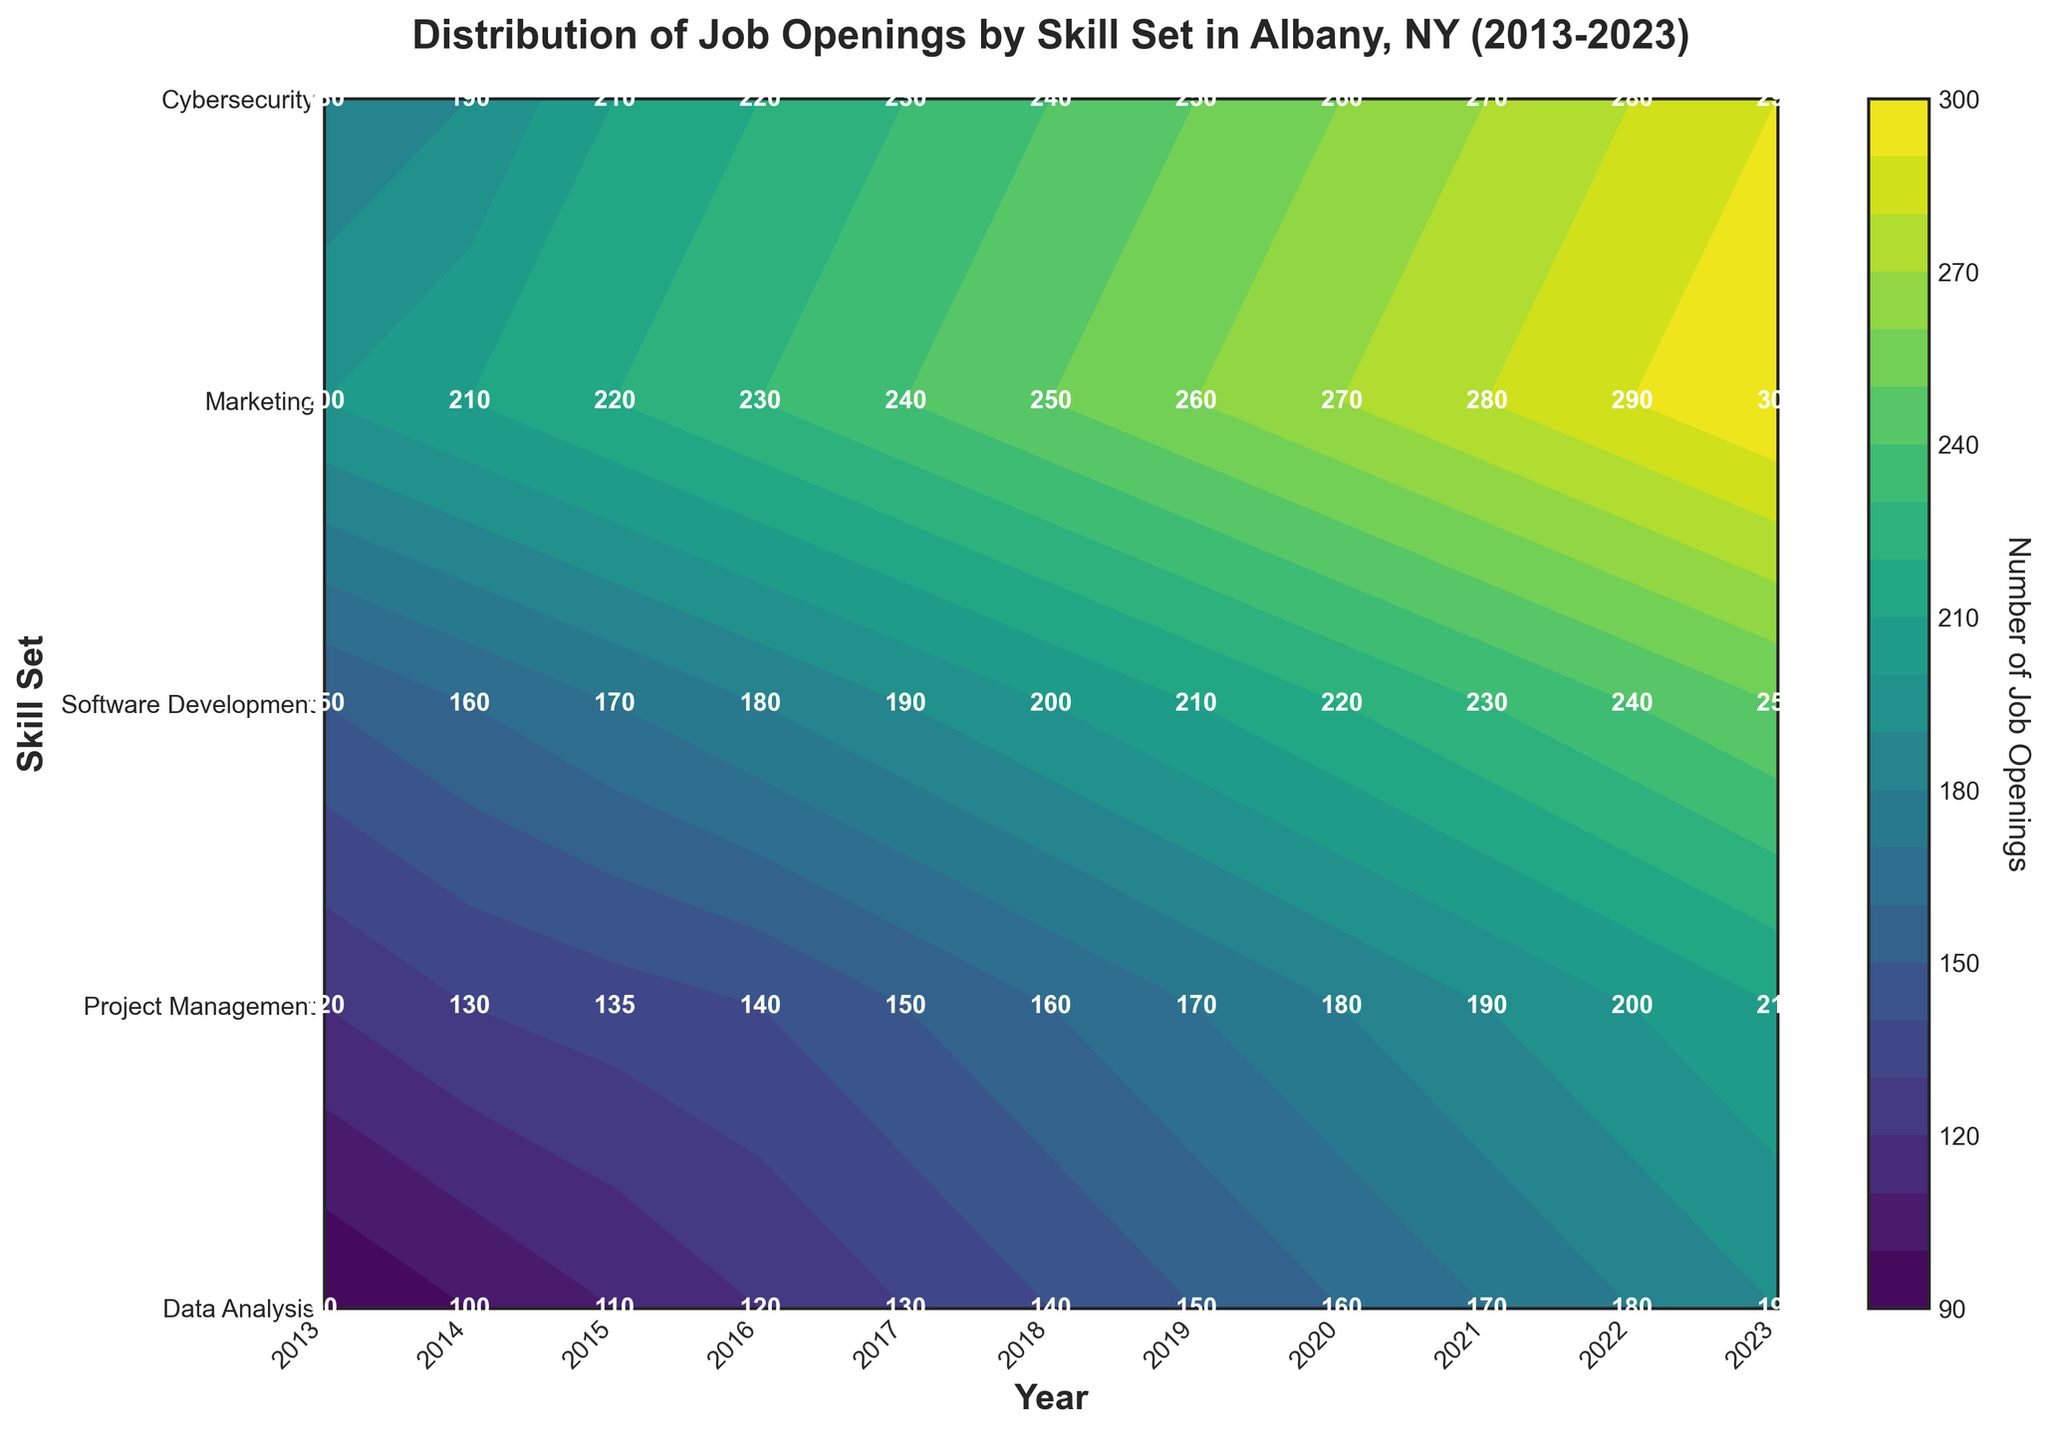What is the title of the figure? The title of the figure is displayed at the top and reads: "Distribution of Job Openings by Skill Set in Albany, NY (2013-2023)."
Answer: Distribution of Job Openings by Skill Set in Albany, NY (2013-2023) What are the skill sets listed on the y-axis? The skill sets are listed on the y-axis in a sequential order from bottom to top. They are Data Analysis, Project Management, Software Development, Marketing, and Cybersecurity.
Answer: Data Analysis, Project Management, Software Development, Marketing, Cybersecurity What is the color representing the highest number of job openings? The highest number of job openings is typically represented by the darkest color in a contour plot. In this case, it is a dark shade of green which corresponds to the 290-300 range for Project Management in 2023.
Answer: Dark Green Which skill set had the least job openings in 2013? Looking at the labels for 2013, the skill set with the least number of job openings in 2013 is Cybersecurity with 90 job openings.
Answer: Cybersecurity Which year had the highest number of job openings overall, and for which skill set? By observing the highest values indicated in each contour, the year with the highest number of job openings is 2023, and the skill set is Project Management with 300 job openings.
Answer: 2023, Project Management What is the trend observed for job openings in Software Development from 2013 to 2023? The trend can be seen by following the progression of numbers from 2013 to 2023 in the row corresponding to Software Development. The job openings increased from 180 in 2013 to 290 in 2023, showing a steady upward trend.
Answer: Upward trend Compare the number of job openings for Data Analysis in 2013 and 2023. To compare these two years, we look at the labels for Data Analysis in both years. In 2013, there were 120 job openings, and in 2023, there were 210. This shows an increase of 90 job openings over the decade.
Answer: Increased by 90 Which skill set showed the smallest increase in job openings from 2013 to 2023? Calculate the difference in job openings for each skill set from 2013 to 2023. Data Analysis increased by 90, Project Management by 100, Software Development by 110, Marketing by 100, and Cybersecurity by 100. The smallest increase is for Data Analysis.
Answer: Data Analysis Find the average number of job openings per year for Marketing between 2013 and 2023. Sum the job openings for Marketing each year and divide by the number of years (11). The sum is: 150 + 160 + 170 + 180 + 190 + 200 + 210 + 220 + 230 + 240 + 250 = 2200. The average is 2200 / 11 ≈ 200.
Answer: 200 